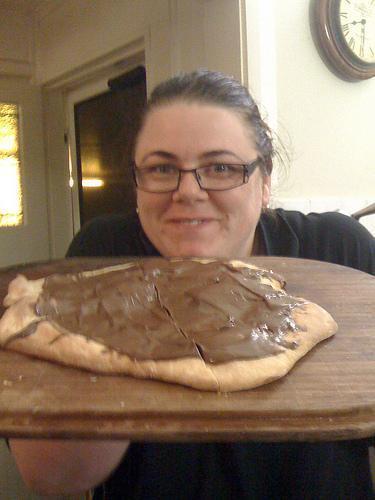How many clocks are visible in this photo?
Give a very brief answer. 1. How many people are pictured here?
Give a very brief answer. 1. 